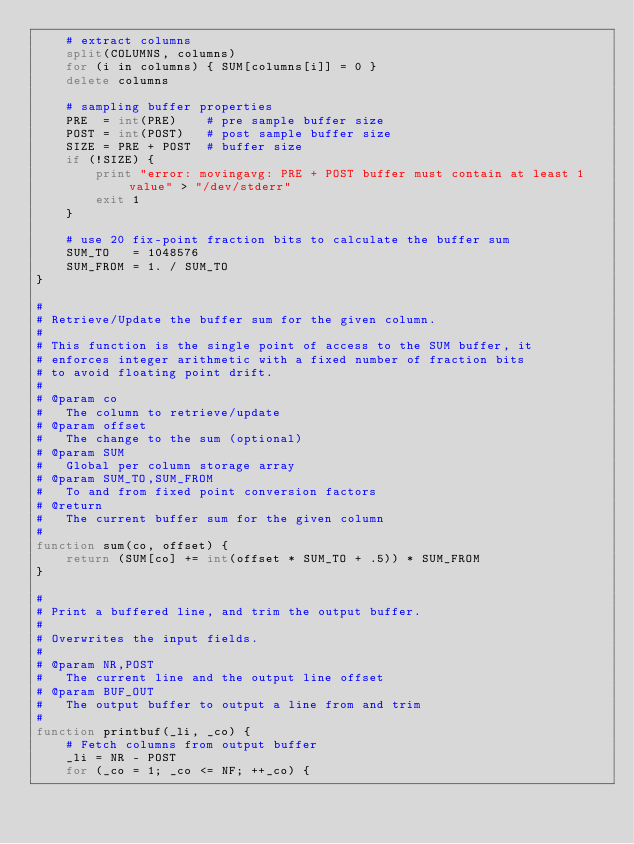Convert code to text. <code><loc_0><loc_0><loc_500><loc_500><_Awk_>	# extract columns
	split(COLUMNS, columns)
	for (i in columns) { SUM[columns[i]] = 0 }
	delete columns

	# sampling buffer properties
	PRE  = int(PRE)    # pre sample buffer size
	POST = int(POST)   # post sample buffer size
	SIZE = PRE + POST  # buffer size
	if (!SIZE) {
		print "error: movingavg: PRE + POST buffer must contain at least 1 value" > "/dev/stderr"
		exit 1
	}

	# use 20 fix-point fraction bits to calculate the buffer sum
	SUM_TO   = 1048576
	SUM_FROM = 1. / SUM_TO
}

#
# Retrieve/Update the buffer sum for the given column.
#
# This function is the single point of access to the SUM buffer, it
# enforces integer arithmetic with a fixed number of fraction bits
# to avoid floating point drift.
#
# @param co
#	The column to retrieve/update
# @param offset
#	The change to the sum (optional)
# @param SUM
#	Global per column storage array
# @param SUM_TO,SUM_FROM
#	To and from fixed point conversion factors
# @return
#	The current buffer sum for the given column
#
function sum(co, offset) {
	return (SUM[co] += int(offset * SUM_TO + .5)) * SUM_FROM
}

#
# Print a buffered line, and trim the output buffer.
#
# Overwrites the input fields.
#
# @param NR,POST
#	The current line and the output line offset
# @param BUF_OUT
#	The output buffer to output a line from and trim
#
function printbuf(_li, _co) {
	# Fetch columns from output buffer
	_li = NR - POST
	for (_co = 1; _co <= NF; ++_co) {</code> 